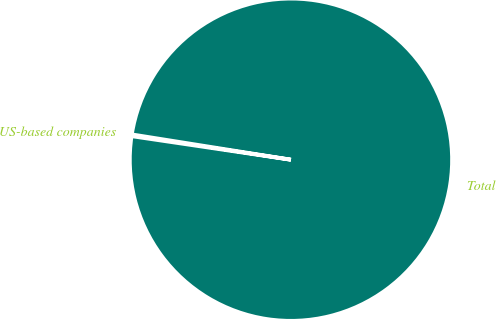Convert chart. <chart><loc_0><loc_0><loc_500><loc_500><pie_chart><fcel>US-based companies<fcel>Total<nl><fcel>0.17%<fcel>99.83%<nl></chart> 